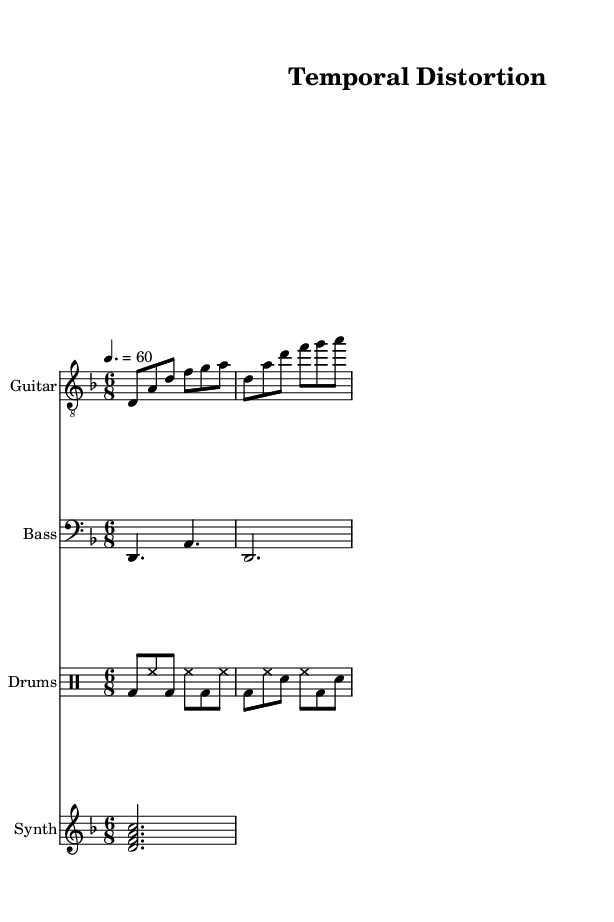What is the key signature of this music? The key signature shown in the sheet music indicates D minor, which has one flat (B flat).
Answer: D minor What is the time signature of this piece? The time signature present in the sheet music is 6/8, which means there are six eighth notes per measure.
Answer: 6/8 What is the tempo marking for this composition? The tempo marking states "4. = 60", indicating that there should be 60 beats per minute, with the quarter note as the beat unit.
Answer: 60 How many measures are in the guitar riff section? The guitar riff consists of two measures, as indicated by the separation of the musical notation into distinct bars.
Answer: 2 What type of drums are used in this piece? The drum part indicates a bass drum (bd), snare drum (sn), and hi-hat (hh), common in metal music to create a rhythmic backbone.
Answer: Bass and snare What is the overall mood reflected in the melody of the guitar? The melody, characterized by its low pitch and repetitive rhythm, conveys a heavy and somber mood typical of doom metal, which often reflects on deeper philosophical themes.
Answer: Somber What is the role of the synth pad in this composition? The synth pad provides harmonic support with sustained chords that enrich the overall texture and atmosphere, characteristic for creating a haunting or expansive backdrop in doom metal tracks.
Answer: Harmonic support 